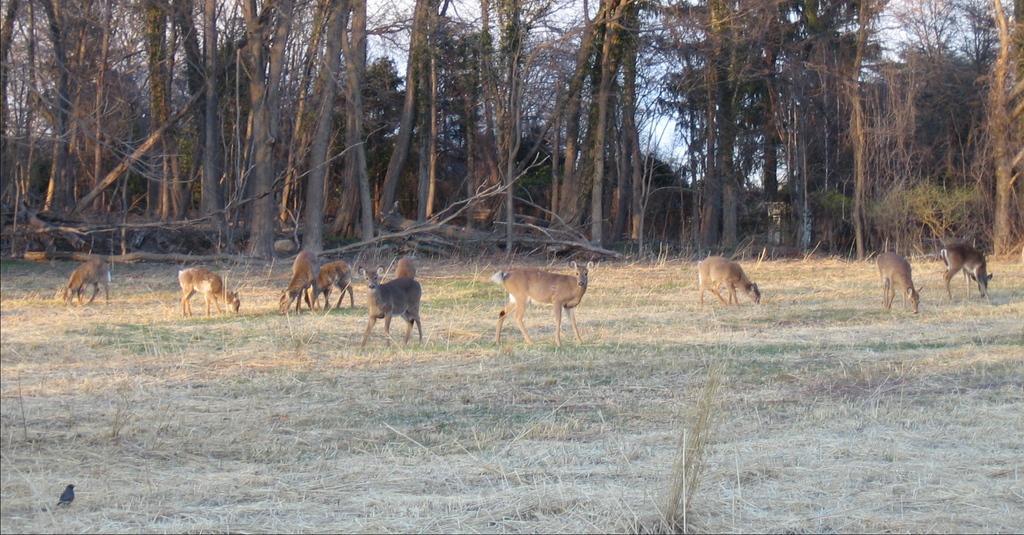Please provide a concise description of this image. There are animals present on a grassy land as we can see in the middle of this image. We can see trees in the background. 